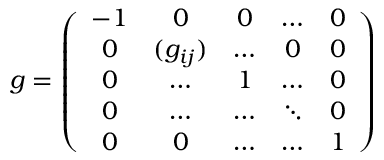Convert formula to latex. <formula><loc_0><loc_0><loc_500><loc_500>g = \left ( \begin{array} { c c c c c } { - 1 } & { 0 } & { 0 } & { \dots } & { 0 } \\ { 0 } & { { ( g _ { i j } ) } } & { \dots } & { 0 } & { 0 } \\ { 0 } & { \dots } & { 1 } & { \dots } & { 0 } \\ { 0 } & { \dots } & { \dots } & { \ddots } & { 0 } \\ { 0 } & { 0 } & { \dots } & { \dots } & { 1 } \end{array} \right )</formula> 